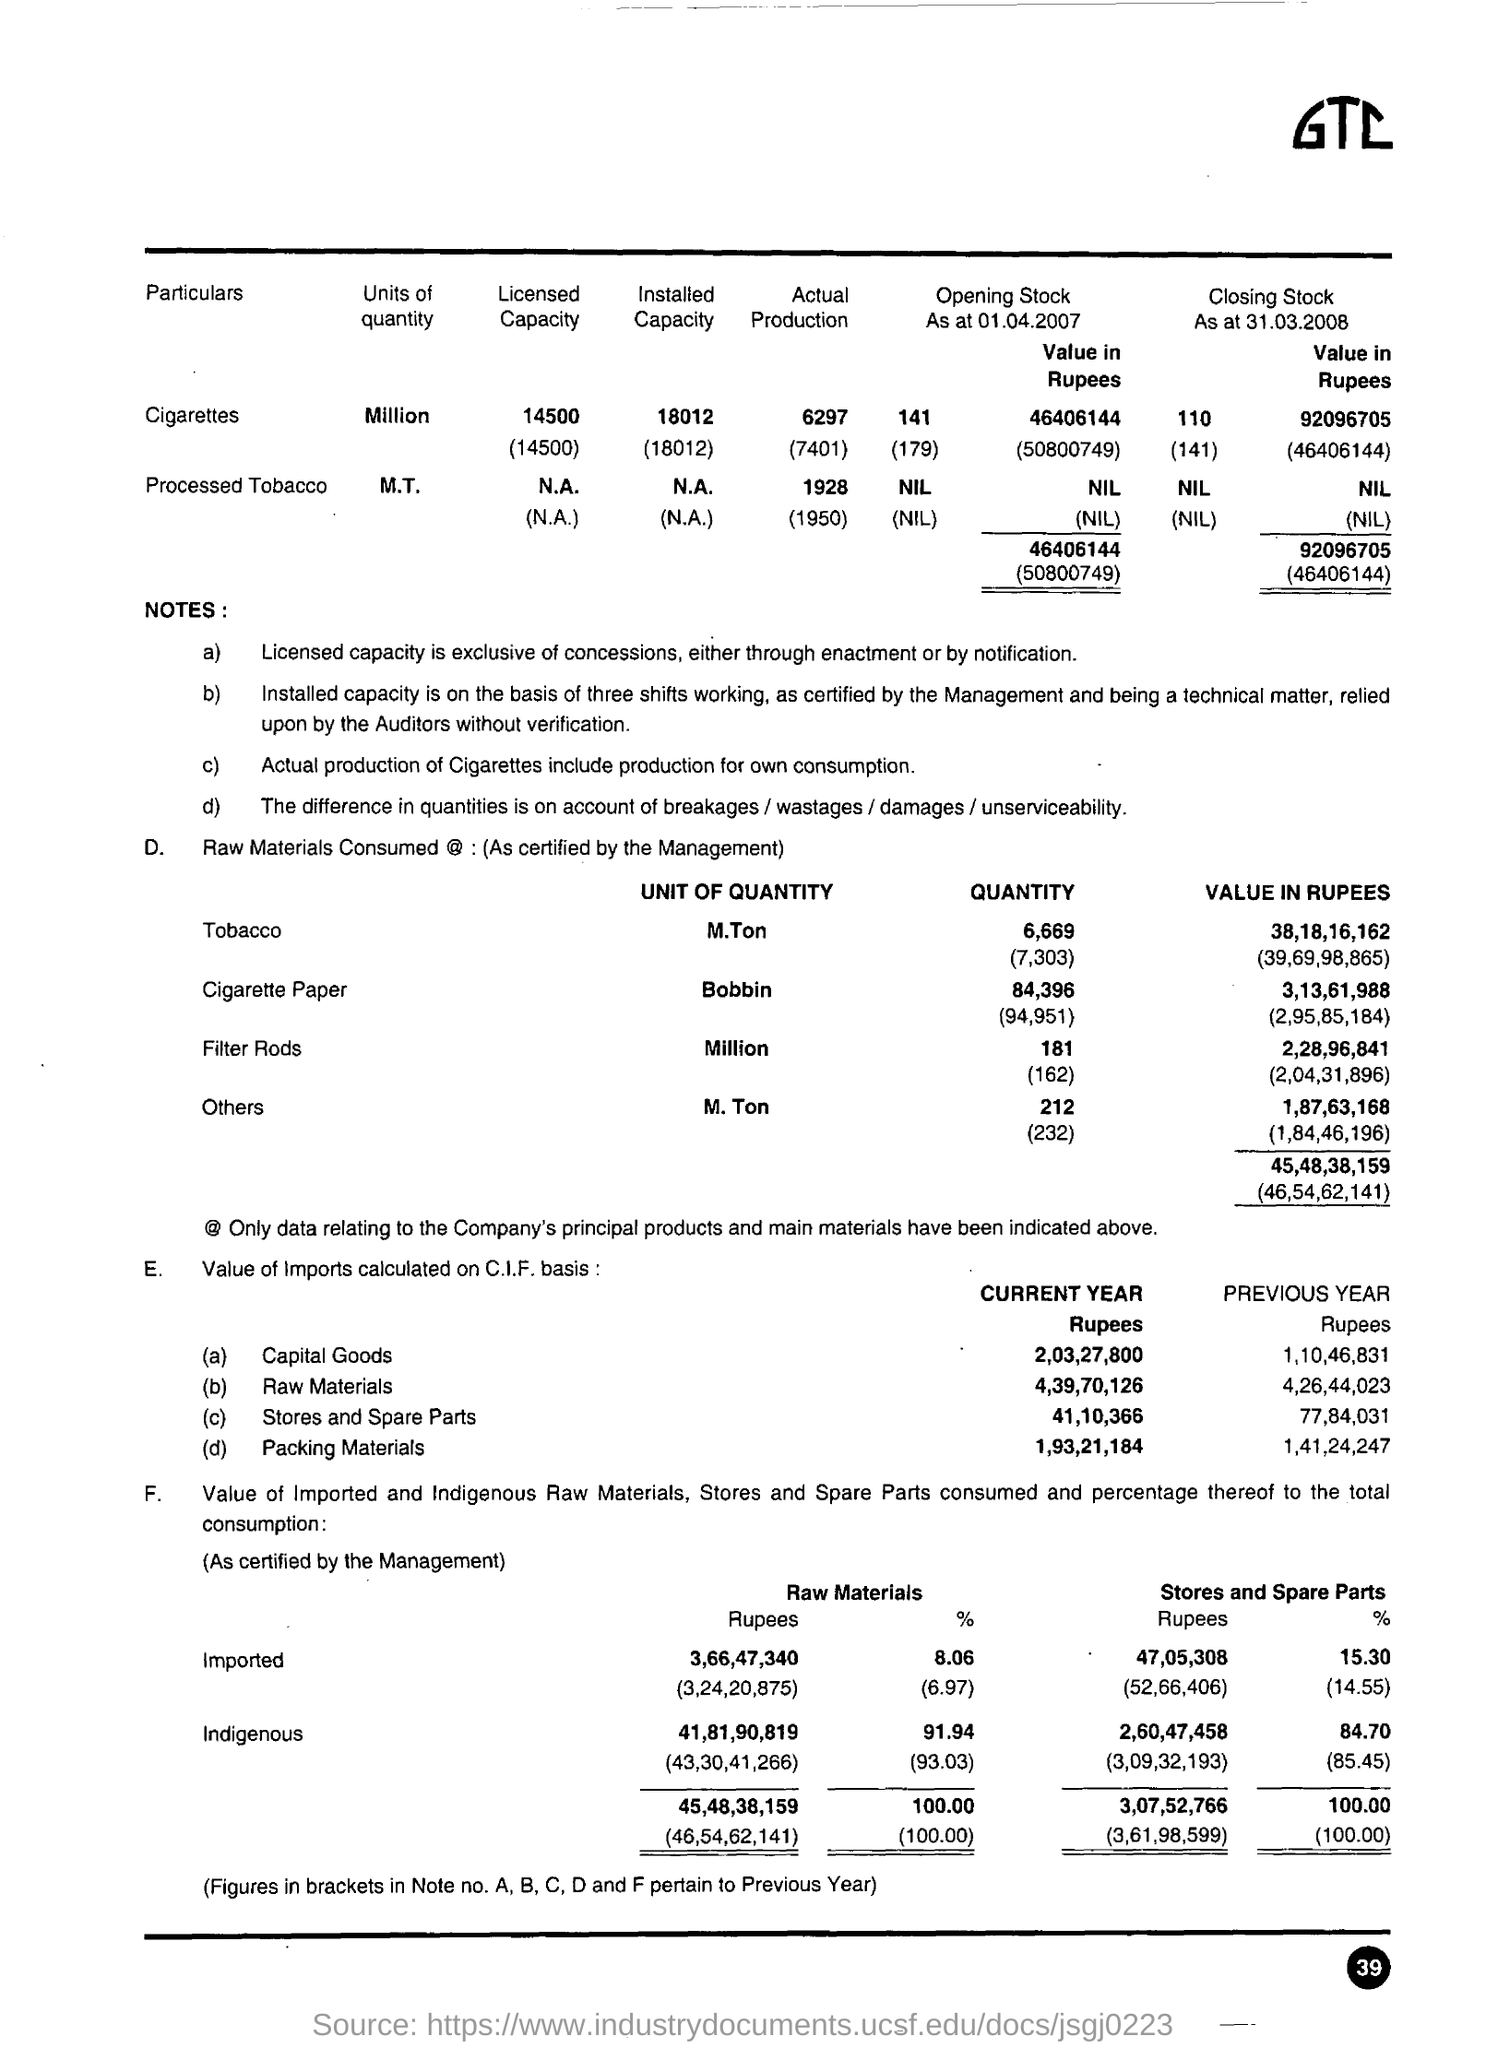What is written on the tp right of the document?
Make the answer very short. GTC. What is the number written in the bottom right of the page?
Make the answer very short. 39. What is mentioned in (a) in the point E?
Your answer should be compact. Capital Goods. 